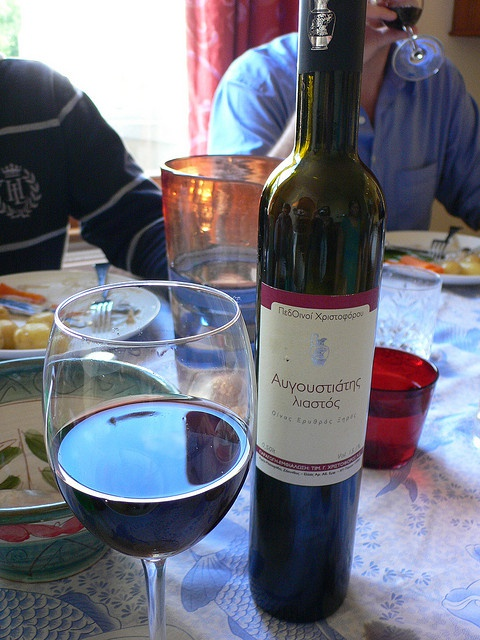Describe the objects in this image and their specific colors. I can see dining table in white, black, darkgray, gray, and lightblue tones, bottle in white, black, darkgray, gray, and navy tones, wine glass in white, gray, darkgray, black, and lightblue tones, people in white, navy, gray, black, and lightblue tones, and people in white, black, gray, and darkblue tones in this image. 